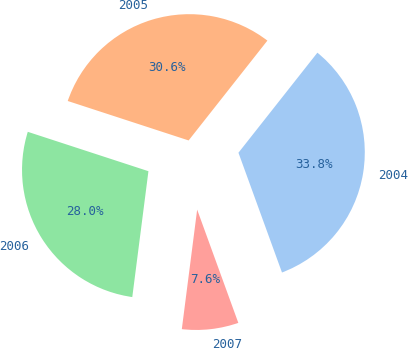<chart> <loc_0><loc_0><loc_500><loc_500><pie_chart><fcel>2004<fcel>2005<fcel>2006<fcel>2007<nl><fcel>33.82%<fcel>30.61%<fcel>27.99%<fcel>7.58%<nl></chart> 